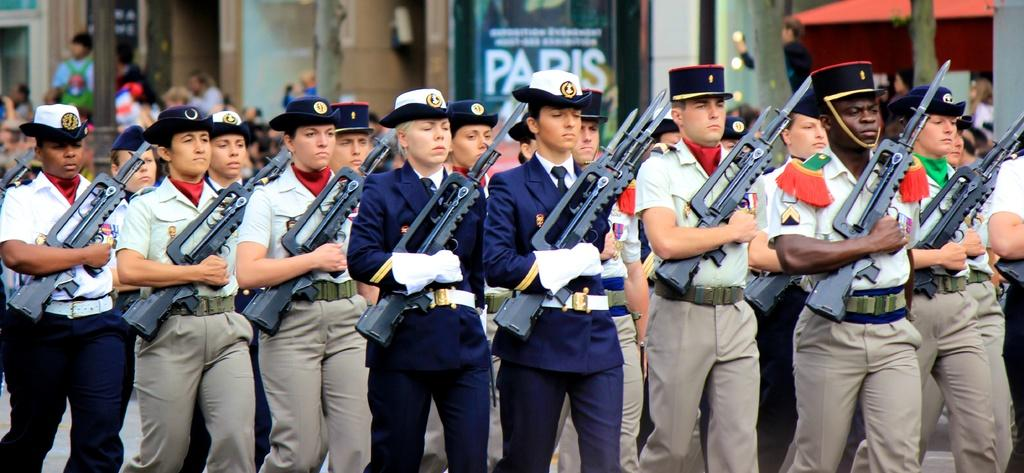What is happening in the image involving the group of people? The people in the image are holding guns in their hands. Can you describe the setting of the image? There are people visible in the background of the image, and there are objects present in the background as well. What type of note is being passed between the people in the image? There is no note being passed between the people in the image; they are holding guns in their hands. Can you see a giraffe in the image? There is no giraffe present in the image. 